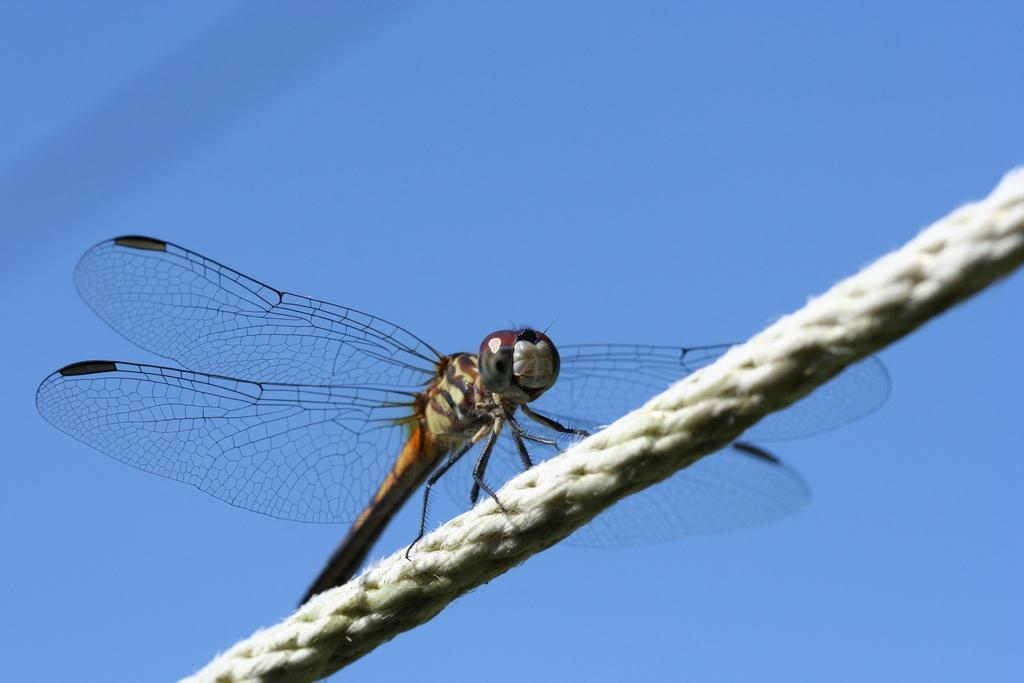In one or two sentences, can you explain what this image depicts? In this picture, there is a dragonfly on the rope. In the background, there is a sky. 